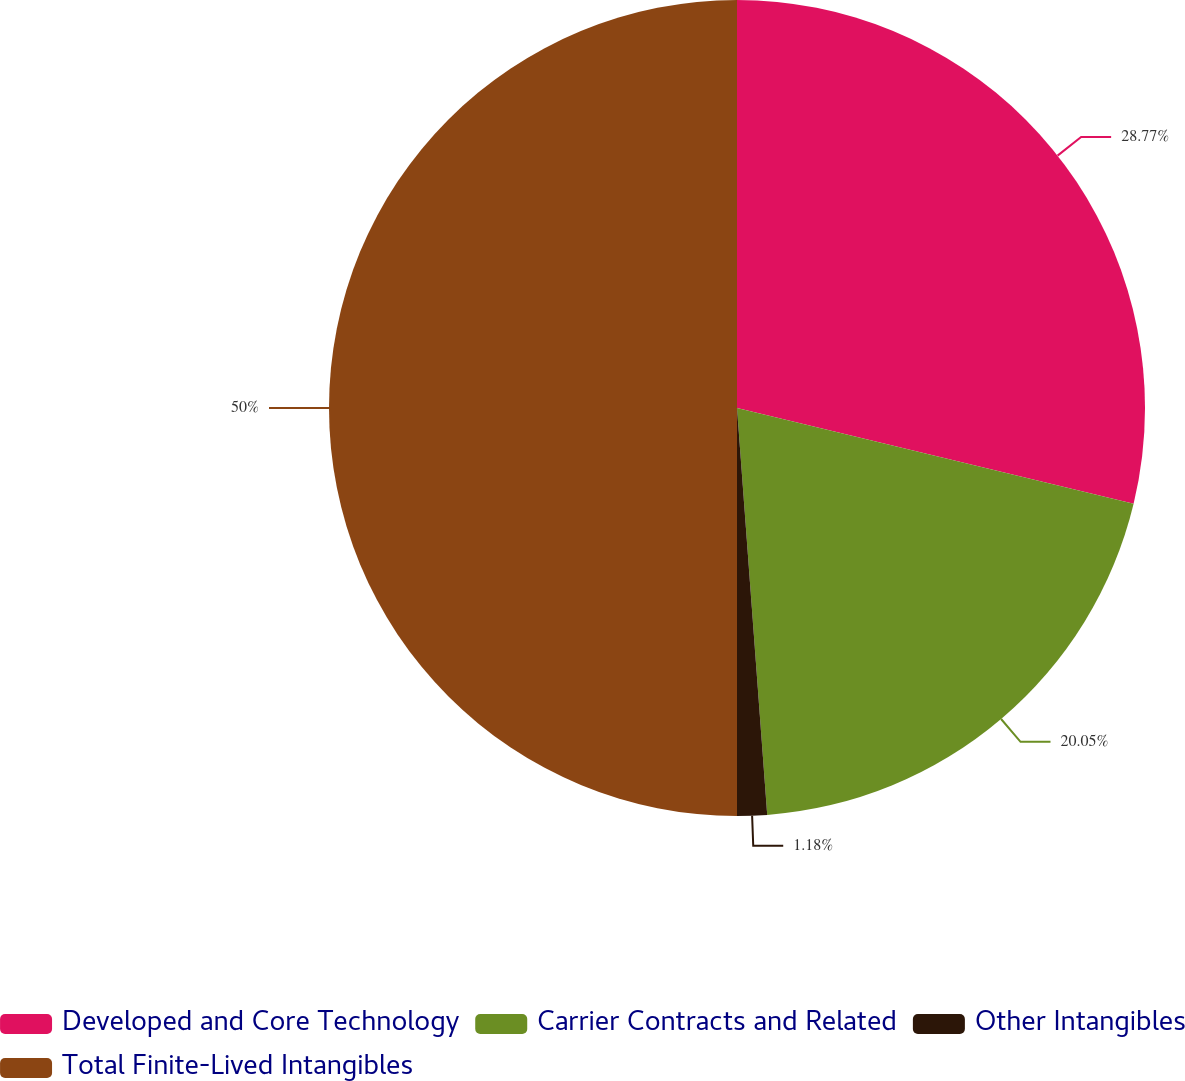<chart> <loc_0><loc_0><loc_500><loc_500><pie_chart><fcel>Developed and Core Technology<fcel>Carrier Contracts and Related<fcel>Other Intangibles<fcel>Total Finite-Lived Intangibles<nl><fcel>28.77%<fcel>20.05%<fcel>1.18%<fcel>50.0%<nl></chart> 